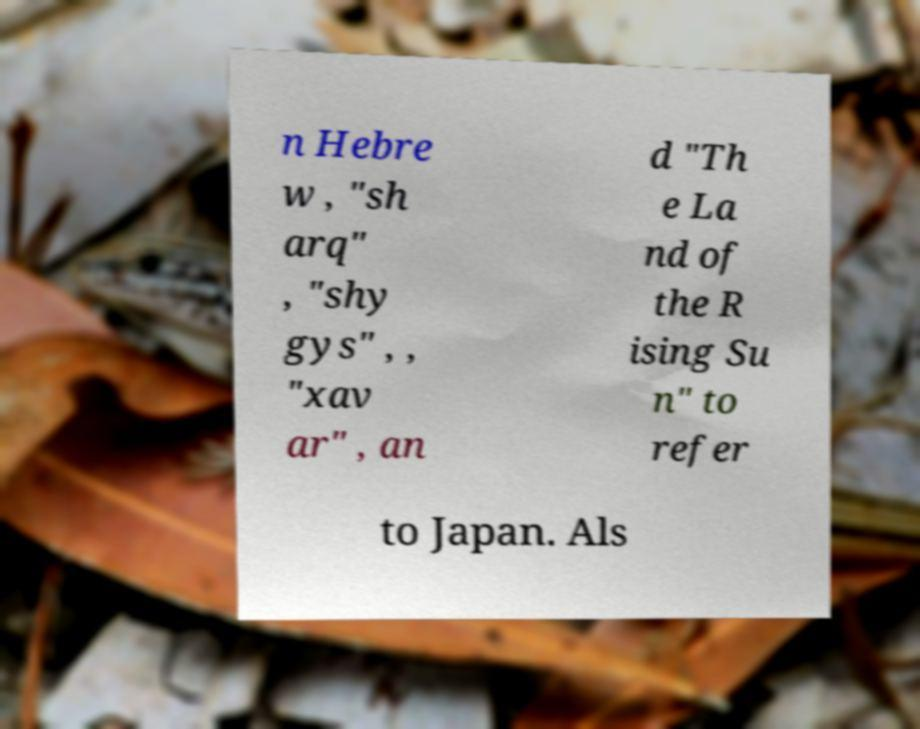Please identify and transcribe the text found in this image. n Hebre w , "sh arq" , "shy gys" , , "xav ar" , an d "Th e La nd of the R ising Su n" to refer to Japan. Als 